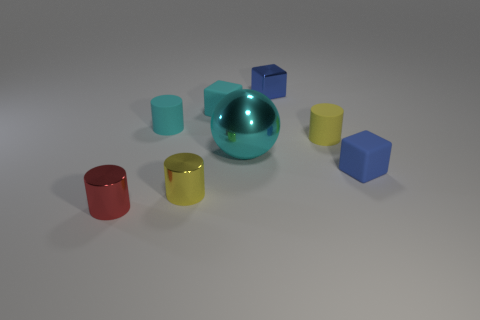What color is the matte cylinder that is right of the big cyan object? yellow 